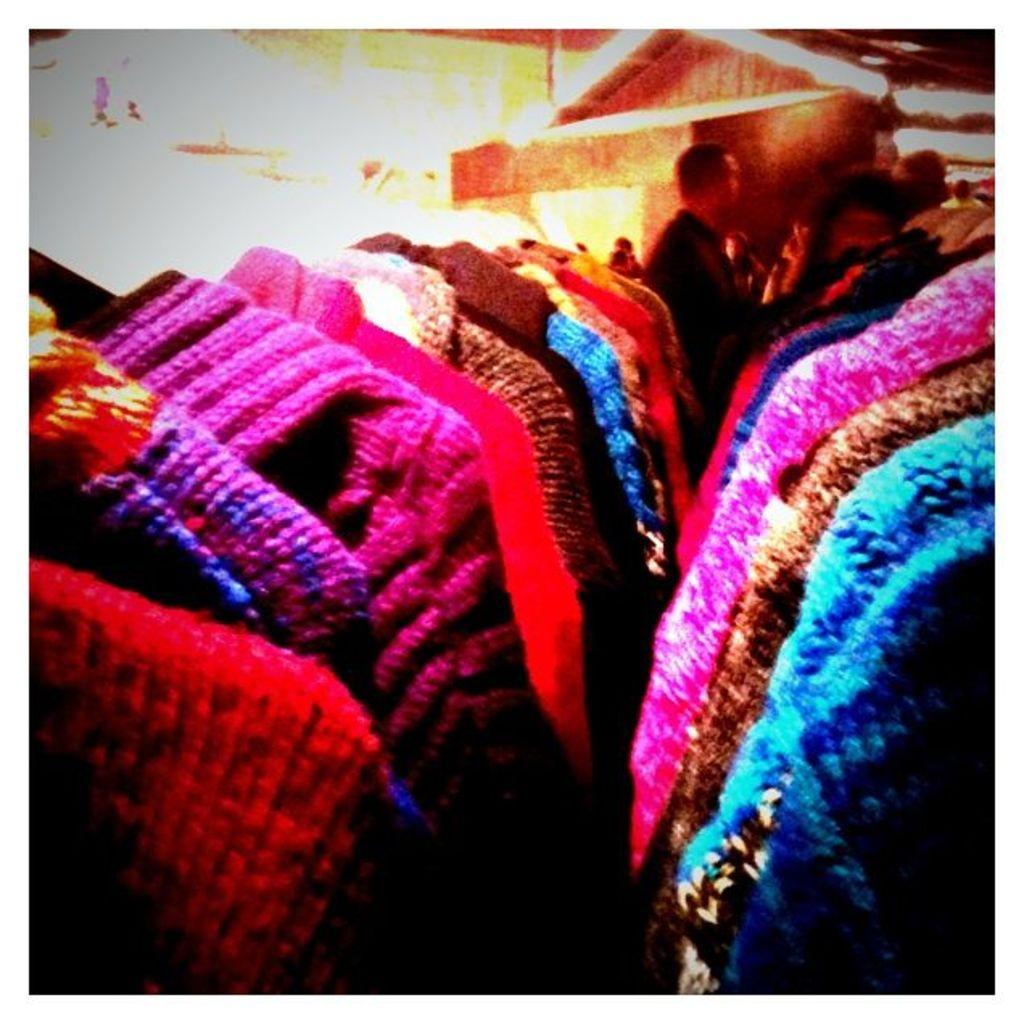What is located in the front of the image? There are clothes in the front of the image. Can you describe the person in the background of the image? Unfortunately, the provided facts do not give any details about the person in the background. What might the clothes be used for? The clothes in the front of the image might be used for wearing or display. How many chairs are visible in the image? There is no mention of chairs in the provided facts, so we cannot determine the number of chairs in the image. 